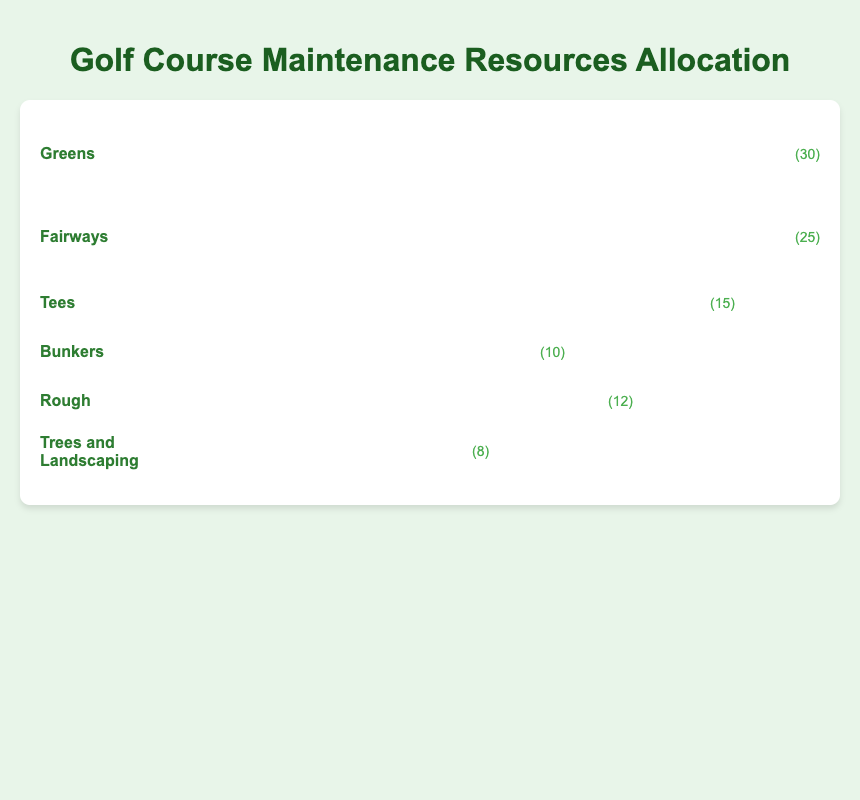What's the area with the highest allocation of resources? The area with the highest allocation of resources is the one with the most icons shown in the figure. Count the icons or look for the largest number next to any of the areas.
Answer: Greens How many more resources are allocated to Fairways compared to Trees and Landscaping? Find the number of resources allocated to Fairways and Trees and Landscaping in the figure. Subtract the smaller number from the larger number to determine the difference. Fairways have 25 resources, and Trees and Landscaping have 8 resources. The difference is 25 - 8.
Answer: 17 What is the total number of resources allocated across all areas? Sum the resources allocated to each area based on the values next to their icons. The areas' resources are 30 (Greens) + 25 (Fairways) + 15 (Tees) + 10 (Bunkers) + 12 (Rough) + 8 (Trees and Landscaping). The total is 30 + 25 + 15 + 10 + 12 + 8.
Answer: 100 Which has fewer resources, Bunkers or Rough? Compare the number of resources on the icons next to Bunkers and Rough. Bunkers have 10 resources and Rough has 12 resources.
Answer: Bunkers What's the difference in resource allocation between Tees and Bunkers? Identify the number of resources for Tees and Bunkers in the figure. Subtract the smaller number from the larger number. Tees have 15 resources and Bunkers have 10, so the difference is 15 - 10.
Answer: 5 What is the average number of resources allocated per area? Sum up the resources for all areas and divide by the number of areas. The total resources are 100, and there are 6 areas. The calculation is 100 / 6.
Answer: 16.67 How does the resource allocation to Rough compare with Trees and Landscaping? Compare the number of resources allocated to Rough and Trees and Landscaping in the figure. Rough has 12 resources and Trees and Landscaping have 8.
Answer: Rough has more If you combine the resources of Tees and Rough, how does that total compare to the resources allocated to Greens? Add the resources of Tees and Rough. Tees have 15 and Rough has 12. The combined resources are 15 + 12. Compare this sum to the resources allocated to Greens, which is 30.
Answer: Less Which specific area uses pruning shears as an icon? Identify the icon displayed next to each area name. The question asks for the area with the pruning shears icon.
Answer: Trees and Landscaping Is the allocation to Fairways greater than the combined allocation of Bunkers and Trees and Landscaping? Calculate the combined resources for Bunkers and Trees and Landscaping. Bunkers have 10 and Trees and Landscaping have 8, so the total is 10 + 8. Compare this sum to Fairways, which is 25.
Answer: Yes 